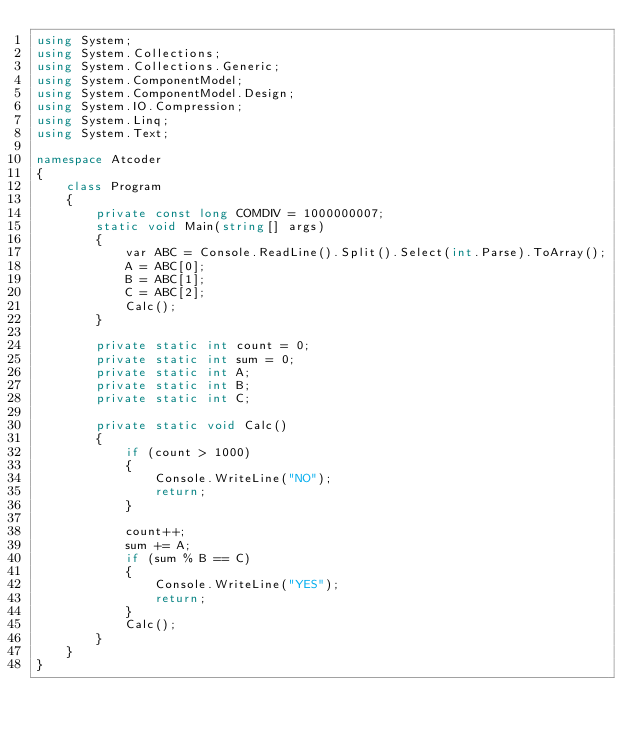<code> <loc_0><loc_0><loc_500><loc_500><_C#_>using System;
using System.Collections;
using System.Collections.Generic;
using System.ComponentModel;
using System.ComponentModel.Design;
using System.IO.Compression;
using System.Linq;
using System.Text;

namespace Atcoder
{
    class Program
    {
        private const long COMDIV = 1000000007;
        static void Main(string[] args)
        {
            var ABC = Console.ReadLine().Split().Select(int.Parse).ToArray();
            A = ABC[0];
            B = ABC[1];
            C = ABC[2];
            Calc();
        }

        private static int count = 0;
        private static int sum = 0;
        private static int A;
        private static int B;
        private static int C;

        private static void Calc()
        {
            if (count > 1000)
            {
                Console.WriteLine("NO");
                return;
            }

            count++;
            sum += A;
            if (sum % B == C)
            {
                Console.WriteLine("YES");
                return;
            }
            Calc();
        }
    }
}</code> 